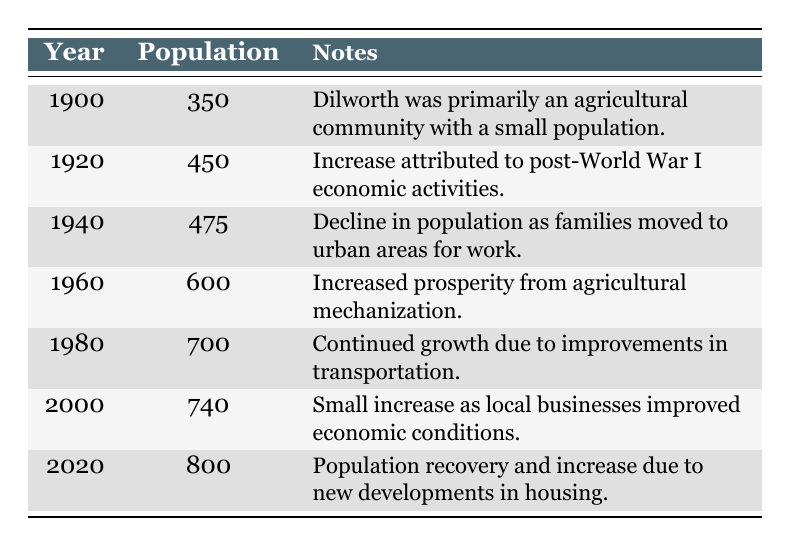What was the population of Dilworth in 1900? The table shows that in the year 1900, the population of Dilworth was listed as 350. Therefore, I can directly refer to this value.
Answer: 350 What year did Dilworth's population reach 600? According to the table, the population of Dilworth reached 600 in the year 1960. This can be found directly by looking at the population values by year.
Answer: 1960 What was the population change from 1940 to 1950? To find the population change, I look at the populations in both years: in 1940, it was 475 and in 1950 it was 520. The change can be calculated as 520 - 475 = 45.
Answer: 45 What is the average population of Dilworth from 1900 to 2020? First, I will list the populations from each year: 350, 400, 450, 500, 475, 520, 600, 650, 700, 720, 740, 730, and 800. The sum of these populations is 7290. There are 13 data points, so the average is 7290 / 13 = 561.54, which I can round to 562 for a whole number.
Answer: 562 Was there a population decline between 1930 and 1940? Looking at the population data, in 1930 the population was 500 and in 1940 it decreased to 475. Since 475 is less than 500, this indicates a decline in population during this period.
Answer: Yes What was the trend in population from 2000 to 2010? In 2000, the population was 740, and in 2010 it decreased to 730. Therefore, the trend shows a slight decline in population over that decade by 10.
Answer: Decline How much did the population of Dilworth increase from 1980 to 2020? In 1980, the population was 700, and by 2020 it had increased to 800. To find the increase, I subtract 700 from 800, which equals 100. Therefore, the population increased by this amount.
Answer: 100 What was the main reason for the population decline in 1940? The notes for 1940 indicate that the decline was due to families moving to urban areas for work. This can be inferred directly from the context provided in the table.
Answer: Families moving to urban areas for work In which decade did Dilworth experience its highest population growth? By examining the population values, I see the highest growth was from 2010 (730) to 2020 (800), resulting in an increase of 70. Comparing this to other decades, this is the largest growth observed.
Answer: 2010-2020 Was the population in 1990 higher than in 1950? In 1990, the population was 720, and in 1950 it was 520. Since 720 is greater than 520, this statement is true.
Answer: Yes 